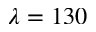<formula> <loc_0><loc_0><loc_500><loc_500>\lambda = 1 3 0</formula> 